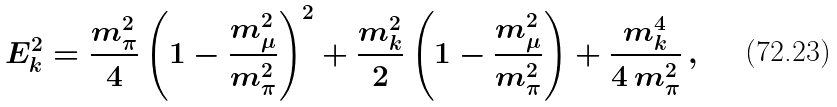Convert formula to latex. <formula><loc_0><loc_0><loc_500><loc_500>E _ { k } ^ { 2 } = \frac { m _ { \pi } ^ { 2 } } { 4 } \left ( 1 - \frac { m _ { \mu } ^ { 2 } } { m _ { \pi } ^ { 2 } } \right ) ^ { 2 } + \frac { m _ { k } ^ { 2 } } { 2 } \left ( 1 - \frac { m _ { \mu } ^ { 2 } } { m _ { \pi } ^ { 2 } } \right ) + \frac { m _ { k } ^ { 4 } } { 4 \, m _ { \pi } ^ { 2 } } \, ,</formula> 